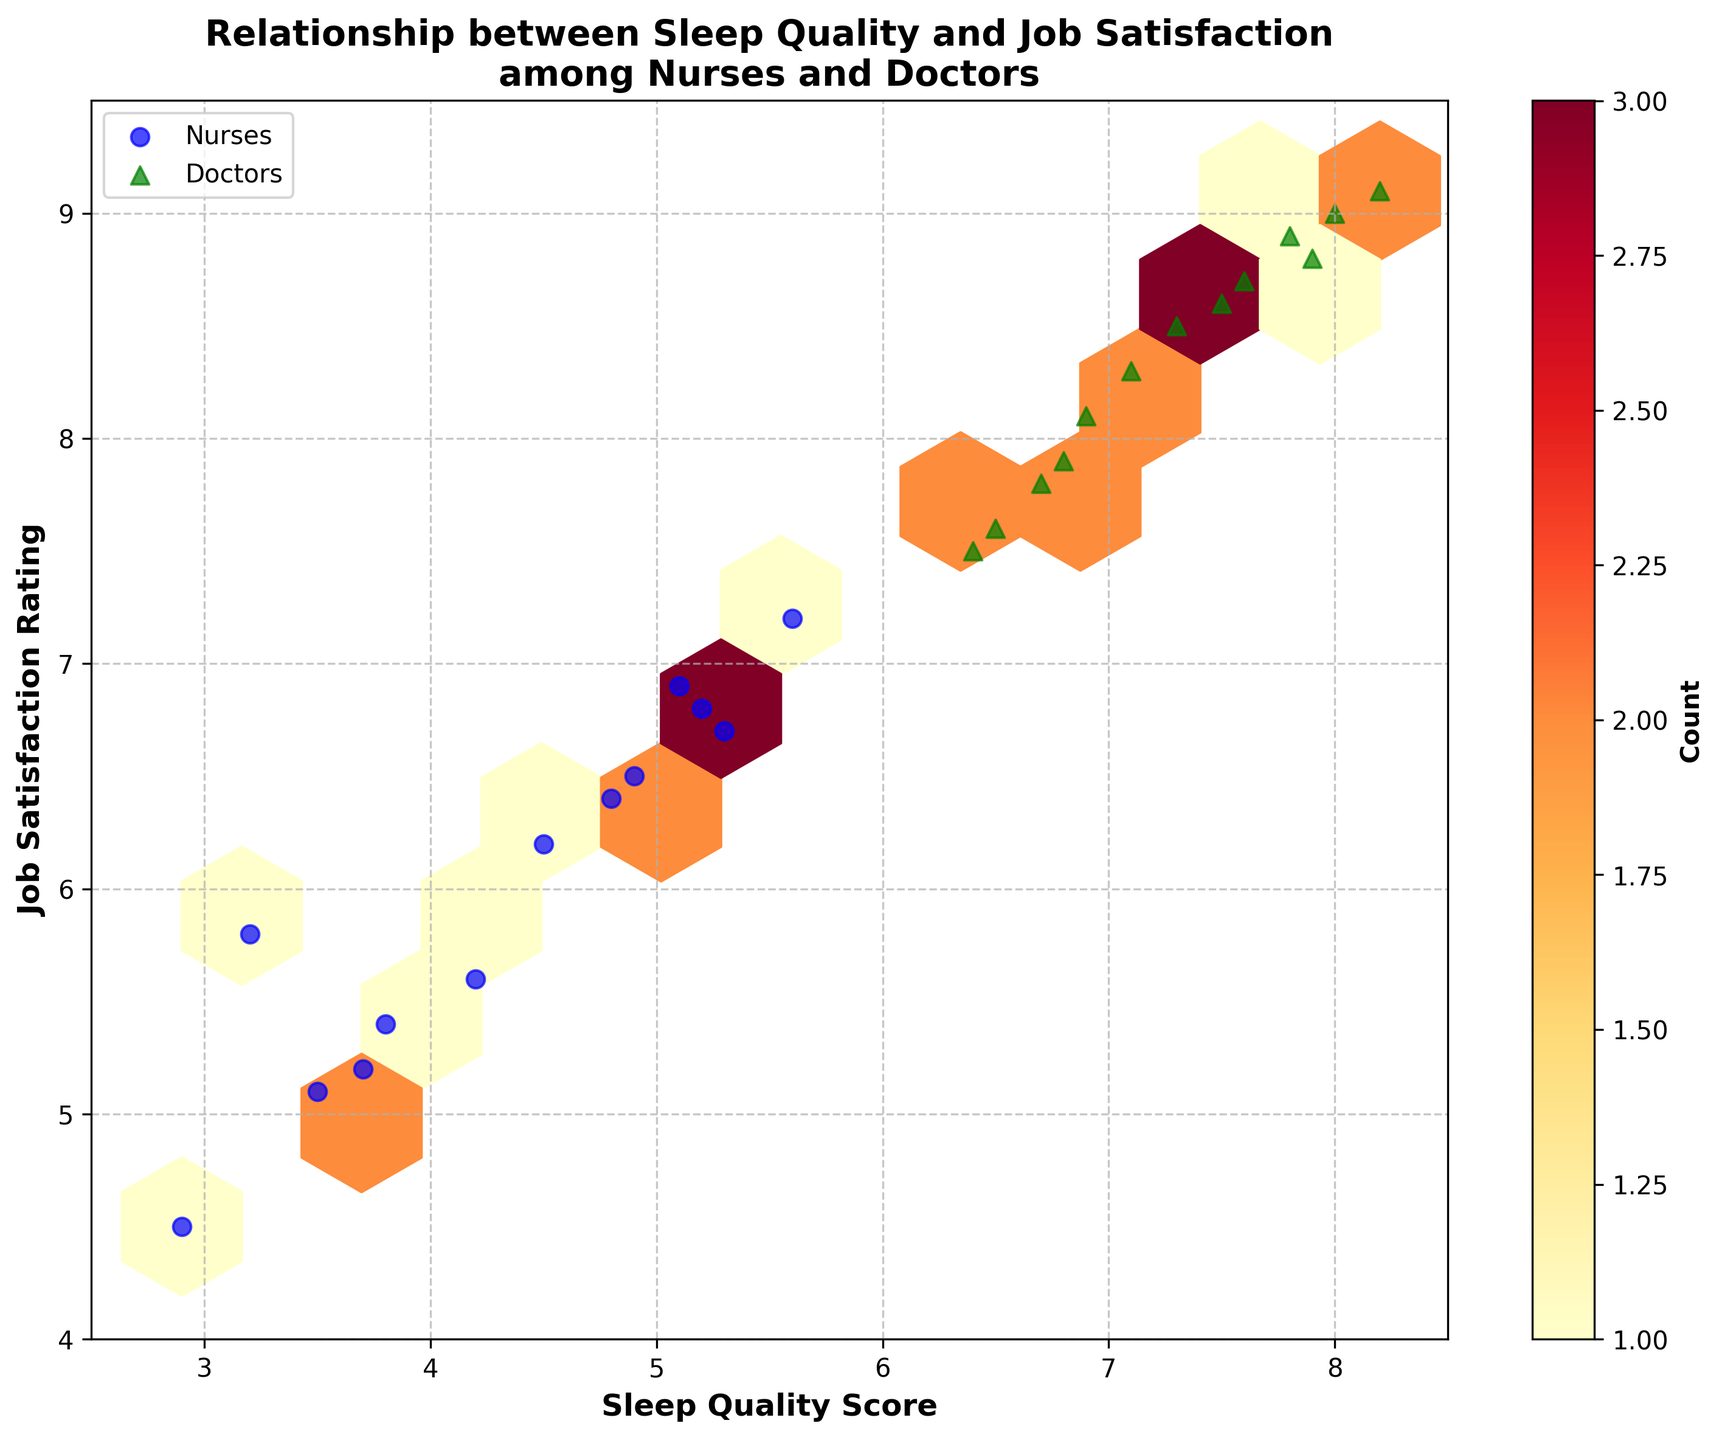What is the title of the plot? The title is located at the top of the plot and is designed to give a clear indication of what the figure is about.
Answer: Relationship between Sleep Quality and Job Satisfaction among Nurses and Doctors What do the colors in the hexagon bin represent? The color intensity in a hexagon bin represents the count of data points that fall within that bin. A color bar on the right side of the plot shows this mapping.
Answer: Count How many unique professions are represented in the scatter plot? We can identify the professions by looking at the legend at the bottom of the plot that lists the different marker styles and their corresponding professions.
Answer: 2 Which profession is represented by the green triangles? By referring to the legend in the plot, we can see that green triangles are designated for a specific profession.
Answer: Doctors In general, do doctors or nurses appear to have higher job satisfaction ratings relative to sleep quality scores? Observing the scatter plot, doctors (green triangles) tend to have higher sleep quality scores and job satisfaction ratings compared to nurses (blue circles).
Answer: Doctors What is the range of sleep quality scores represented in the plot? By examining the x-axis, we can see the minimum and maximum values for sleep quality scores plotted in the figure.
Answer: 2.5 to 8.5 What is the median sleep quality score for the data points? To find the median, we first list the sleep quality scores in order: 2.9, 3.2, 3.5, 3.7, 3.8, 4.2, 4.5, 4.8, 4.9, 5.1, 5.2, 5.3, 5.6, 6.4, 6.5, 6.7, 6.8, 6.9, 7.1, 7.3, 7.5, 7.6, 7.8, 7.9, 8.0, 8.2. The middle value(s) here are 5.3 and 5.6, so the median is the average of these two: (5.3 + 5.6) / 2.
Answer: 5.45 What grid size was used for the hexbin plot? The grid size value is not directly depicted in the plot. However, it's mentioned in the provided code that a grid size of 10 was used to create the hexbin plot.
Answer: 10 Which cluster type specific region in the hexbin plot has the highest concentration of data points? According to the color intensity within the hexagon bins and the color bar, the bin with the highest concentration is the darkest one.
Answer: Bin with highest intensity If we categorized sleep quality scores above 6 as "high" and those 6 or below as "low," which category would have a higher job satisfaction score based on the scatter plot? Upon inspection, data points with sleep quality scores higher than 6 (typically doctors) also correlate with job satisfaction scores that are higher.
Answer: High 